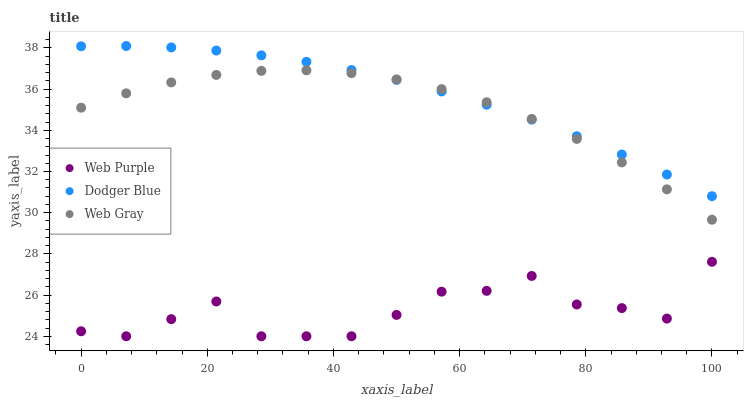Does Web Purple have the minimum area under the curve?
Answer yes or no. Yes. Does Dodger Blue have the maximum area under the curve?
Answer yes or no. Yes. Does Web Gray have the minimum area under the curve?
Answer yes or no. No. Does Web Gray have the maximum area under the curve?
Answer yes or no. No. Is Dodger Blue the smoothest?
Answer yes or no. Yes. Is Web Purple the roughest?
Answer yes or no. Yes. Is Web Gray the smoothest?
Answer yes or no. No. Is Web Gray the roughest?
Answer yes or no. No. Does Web Purple have the lowest value?
Answer yes or no. Yes. Does Web Gray have the lowest value?
Answer yes or no. No. Does Dodger Blue have the highest value?
Answer yes or no. Yes. Does Web Gray have the highest value?
Answer yes or no. No. Is Web Purple less than Web Gray?
Answer yes or no. Yes. Is Web Gray greater than Web Purple?
Answer yes or no. Yes. Does Dodger Blue intersect Web Gray?
Answer yes or no. Yes. Is Dodger Blue less than Web Gray?
Answer yes or no. No. Is Dodger Blue greater than Web Gray?
Answer yes or no. No. Does Web Purple intersect Web Gray?
Answer yes or no. No. 